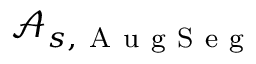<formula> <loc_0><loc_0><loc_500><loc_500>\mathcal { A } _ { s , A u g S e g }</formula> 